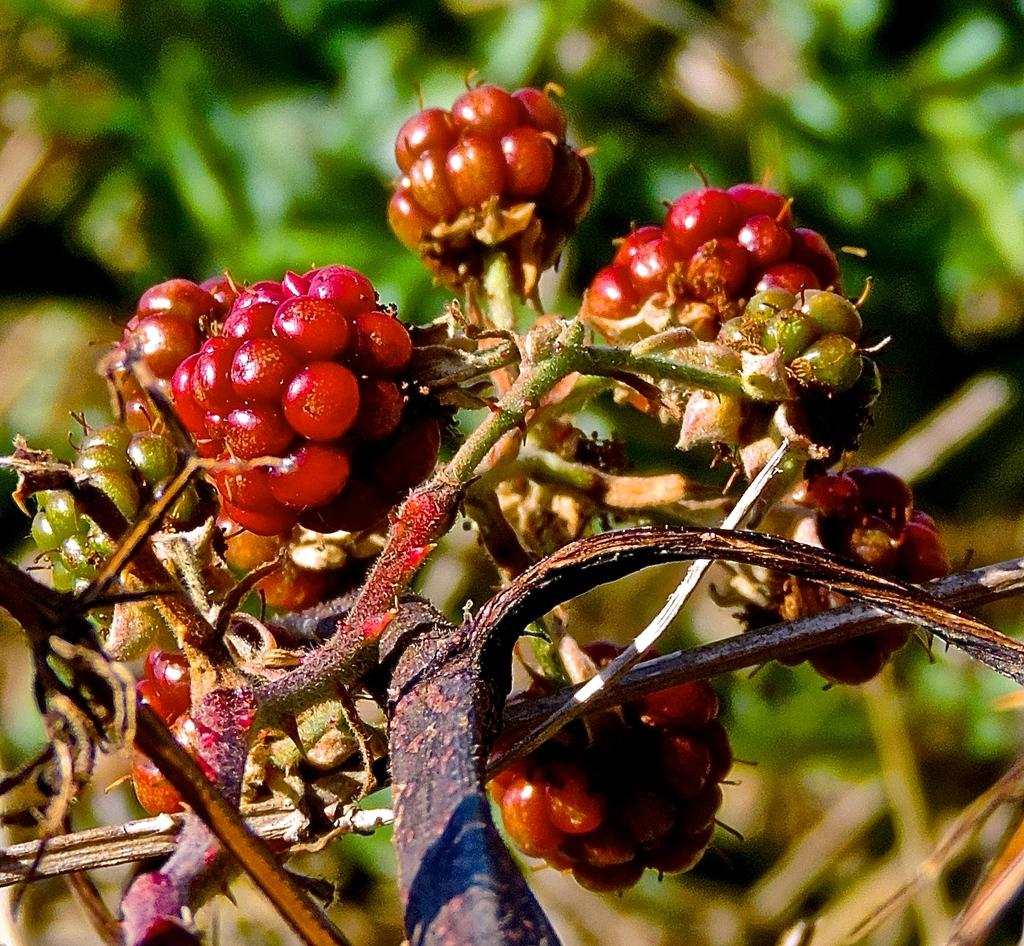What type of fruit is visible on the plant in the image? There are berries on the stem of a plant in the image. Can you observe any trains passing by in the image? There are no trains present in the image. Is there a snail visible on the plant in the image? There is no snail visible on the plant in the image. 